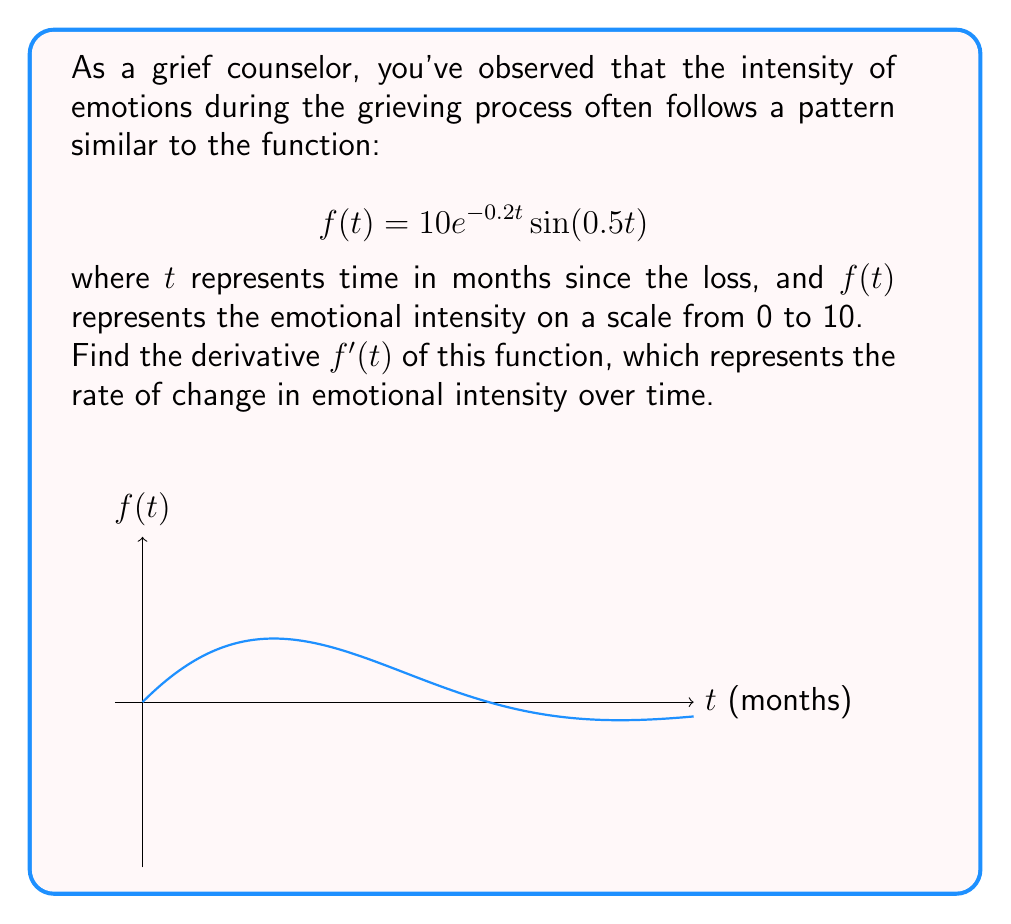Teach me how to tackle this problem. To find the derivative of $f(t) = 10e^{-0.2t}\sin(0.5t)$, we need to use the product rule since this is a product of two functions.

Let $u = 10e^{-0.2t}$ and $v = \sin(0.5t)$

The product rule states that $(uv)' = u'v + uv'$

Step 1: Find $u'$
$u' = 10 \cdot (-0.2)e^{-0.2t} = -2e^{-0.2t}$

Step 2: Find $v'$
$v' = 0.5\cos(0.5t)$

Step 3: Apply the product rule
$f'(t) = u'v + uv'$
$f'(t) = (-2e^{-0.2t})\sin(0.5t) + (10e^{-0.2t})(0.5\cos(0.5t))$

Step 4: Simplify
$f'(t) = -2e^{-0.2t}\sin(0.5t) + 5e^{-0.2t}\cos(0.5t)$

Step 5: Factor out $e^{-0.2t}$
$f'(t) = e^{-0.2t}[-2\sin(0.5t) + 5\cos(0.5t)]$
Answer: $f'(t) = e^{-0.2t}[-2\sin(0.5t) + 5\cos(0.5t)]$ 